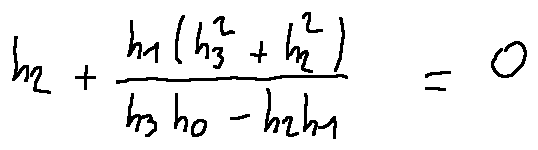Convert formula to latex. <formula><loc_0><loc_0><loc_500><loc_500>h _ { 2 } + \frac { h _ { 1 } ( h _ { 3 } ^ { 2 } + h _ { 2 } ^ { 2 } ) } { h _ { 3 } h _ { 0 } - h _ { 2 } h _ { 1 } } = 0</formula> 